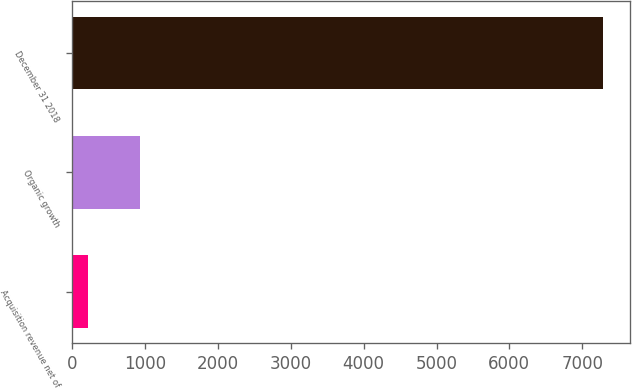<chart> <loc_0><loc_0><loc_500><loc_500><bar_chart><fcel>Acquisition revenue net of<fcel>Organic growth<fcel>December 31 2018<nl><fcel>217.9<fcel>925.15<fcel>7290.4<nl></chart> 